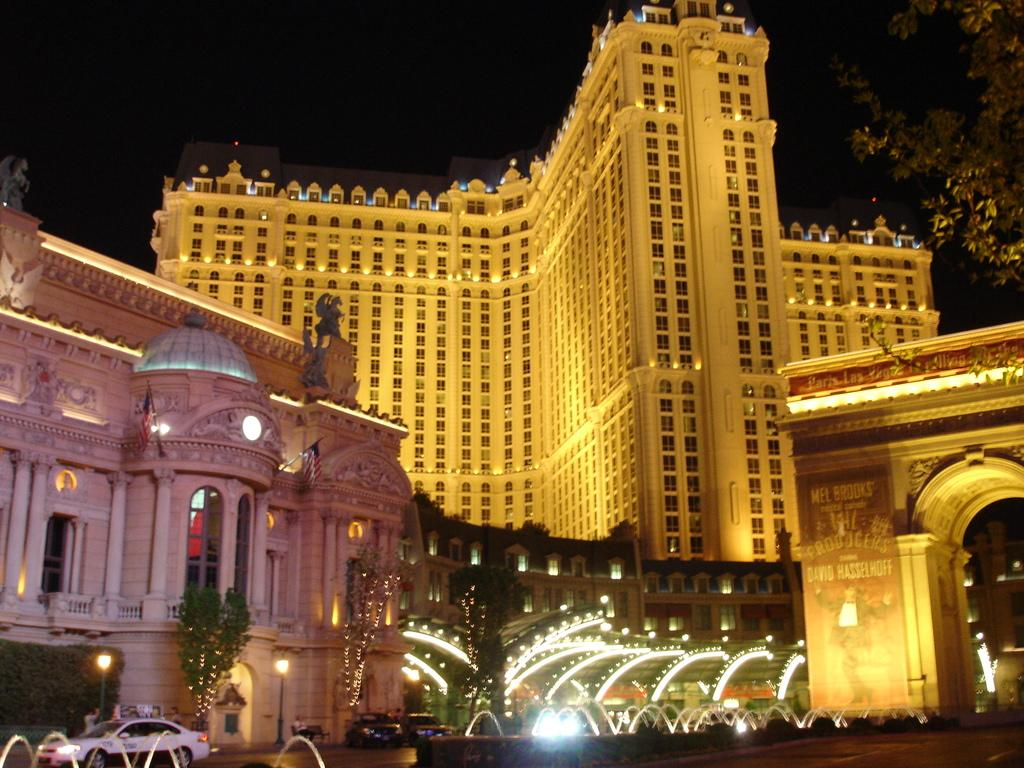What type of structures can be seen in the image? There are buildings in the image. What other natural elements are present in the image? There are trees in the image. What mode of transportation can be seen on the road in the image? There are vehicles on the road in the image. What can be seen illuminating the scene in the image? There are lights visible in the image. What type of soap is being used to clean the can in the image? There is no soap or can present in the image. How many people are jumping in the image? There are no people jumping in the image. 